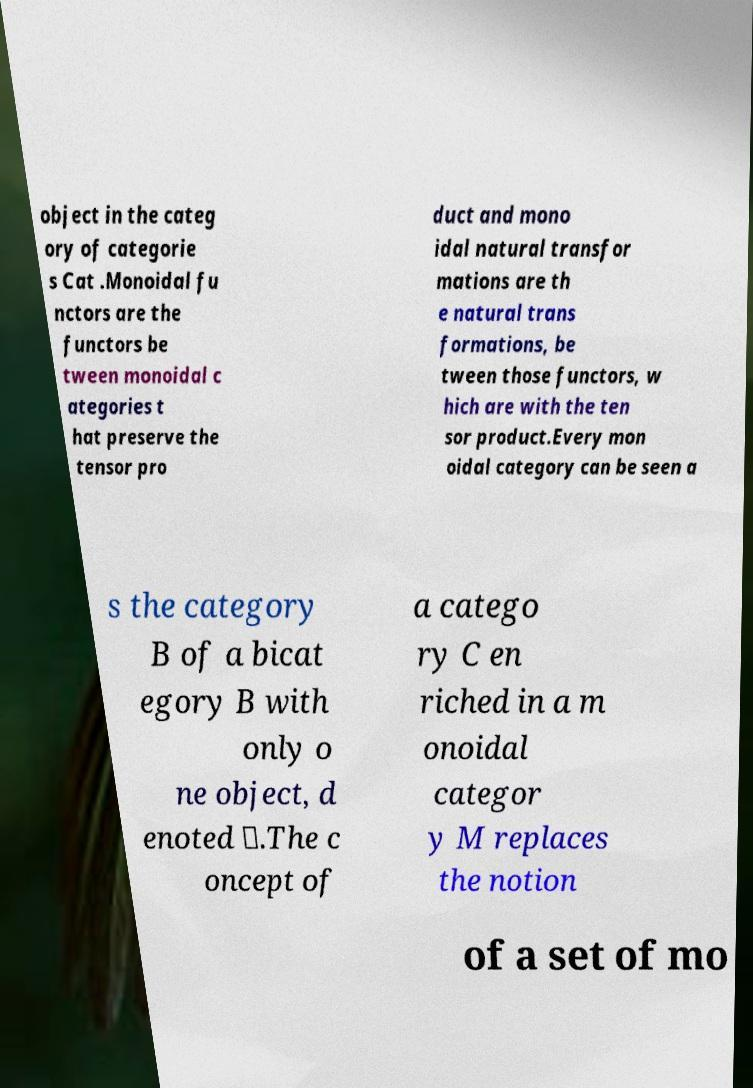Can you accurately transcribe the text from the provided image for me? object in the categ ory of categorie s Cat .Monoidal fu nctors are the functors be tween monoidal c ategories t hat preserve the tensor pro duct and mono idal natural transfor mations are th e natural trans formations, be tween those functors, w hich are with the ten sor product.Every mon oidal category can be seen a s the category B of a bicat egory B with only o ne object, d enoted ∗.The c oncept of a catego ry C en riched in a m onoidal categor y M replaces the notion of a set of mo 